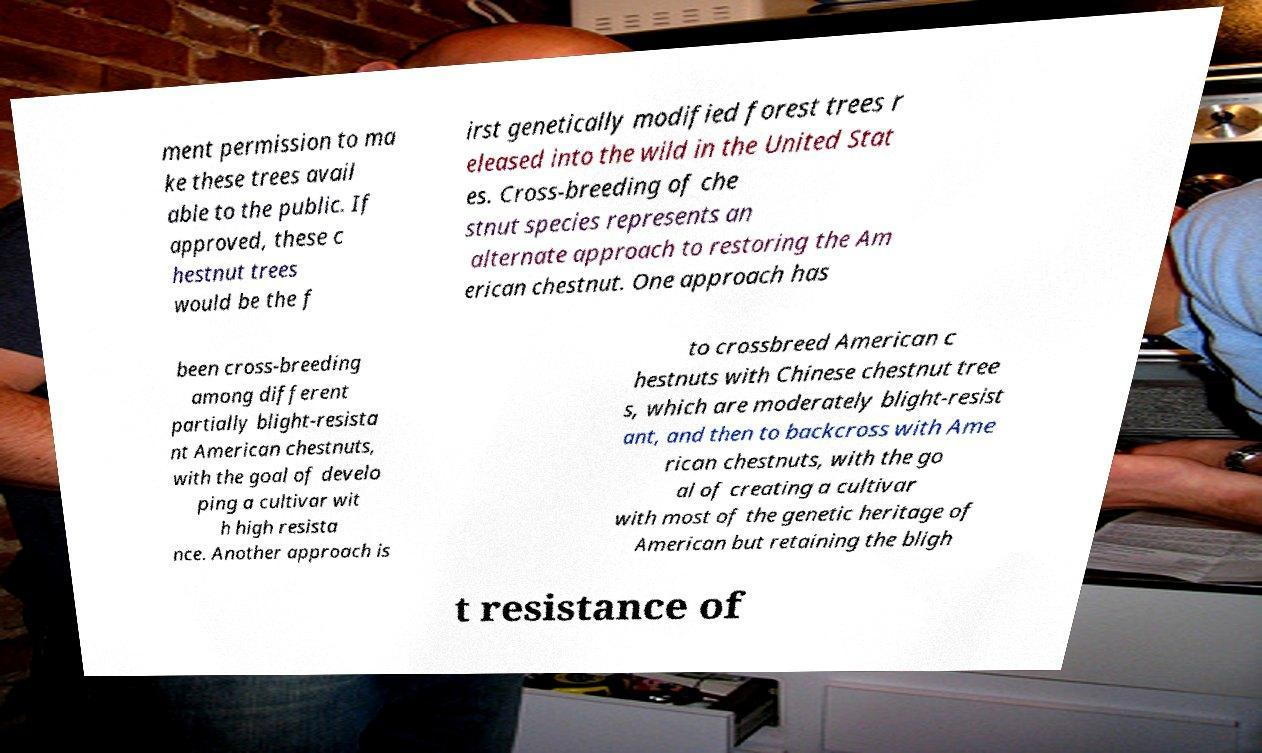What messages or text are displayed in this image? I need them in a readable, typed format. ment permission to ma ke these trees avail able to the public. If approved, these c hestnut trees would be the f irst genetically modified forest trees r eleased into the wild in the United Stat es. Cross-breeding of che stnut species represents an alternate approach to restoring the Am erican chestnut. One approach has been cross-breeding among different partially blight-resista nt American chestnuts, with the goal of develo ping a cultivar wit h high resista nce. Another approach is to crossbreed American c hestnuts with Chinese chestnut tree s, which are moderately blight-resist ant, and then to backcross with Ame rican chestnuts, with the go al of creating a cultivar with most of the genetic heritage of American but retaining the bligh t resistance of 